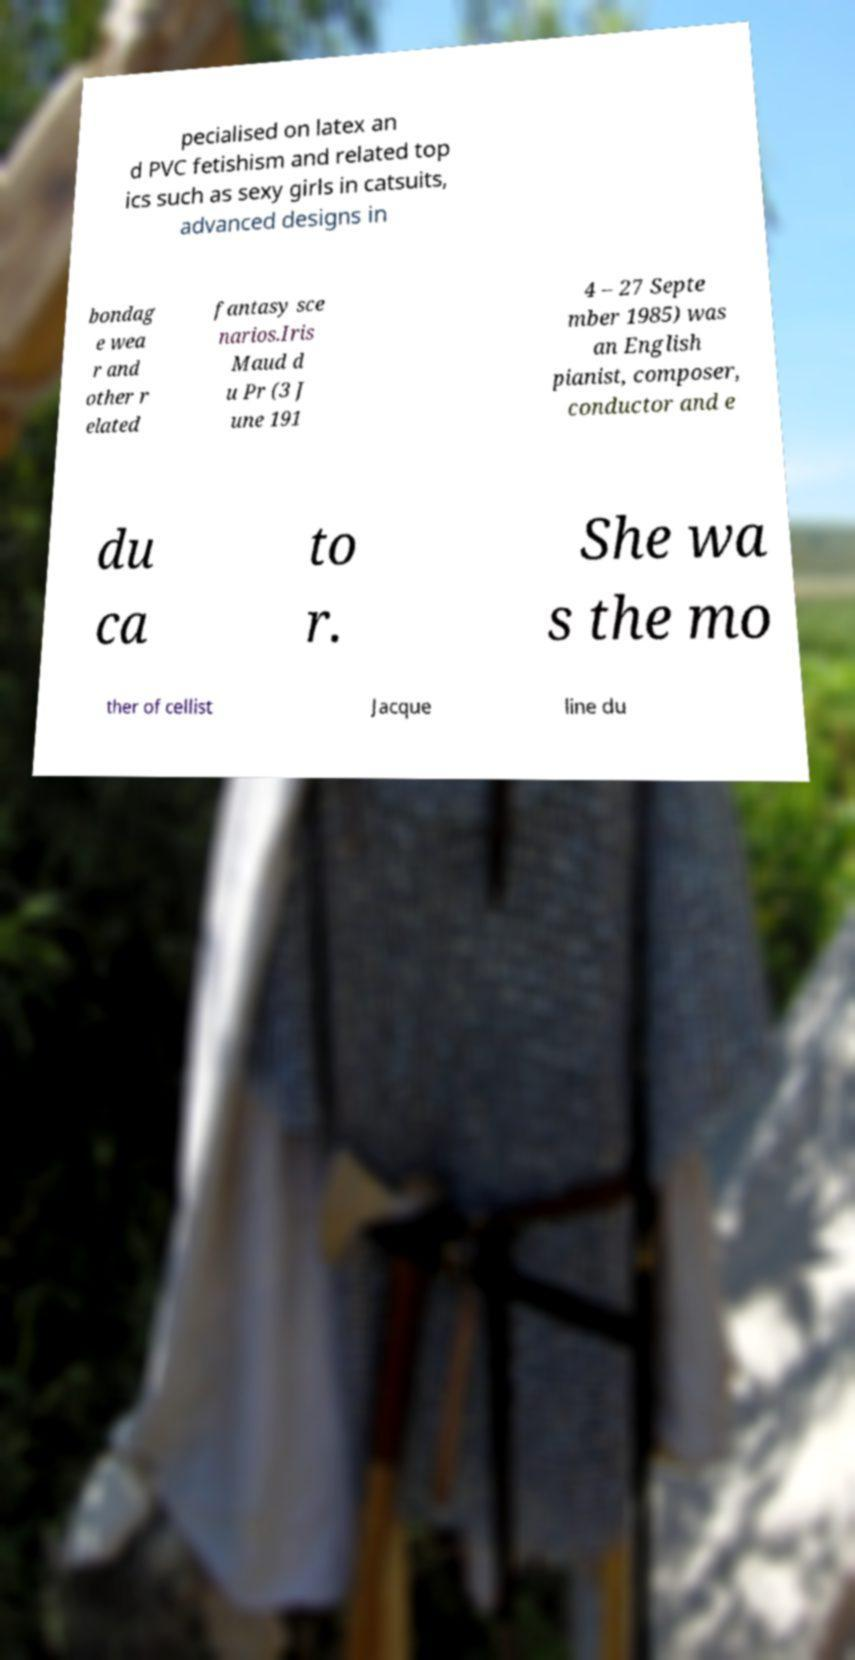For documentation purposes, I need the text within this image transcribed. Could you provide that? pecialised on latex an d PVC fetishism and related top ics such as sexy girls in catsuits, advanced designs in bondag e wea r and other r elated fantasy sce narios.Iris Maud d u Pr (3 J une 191 4 – 27 Septe mber 1985) was an English pianist, composer, conductor and e du ca to r. She wa s the mo ther of cellist Jacque line du 